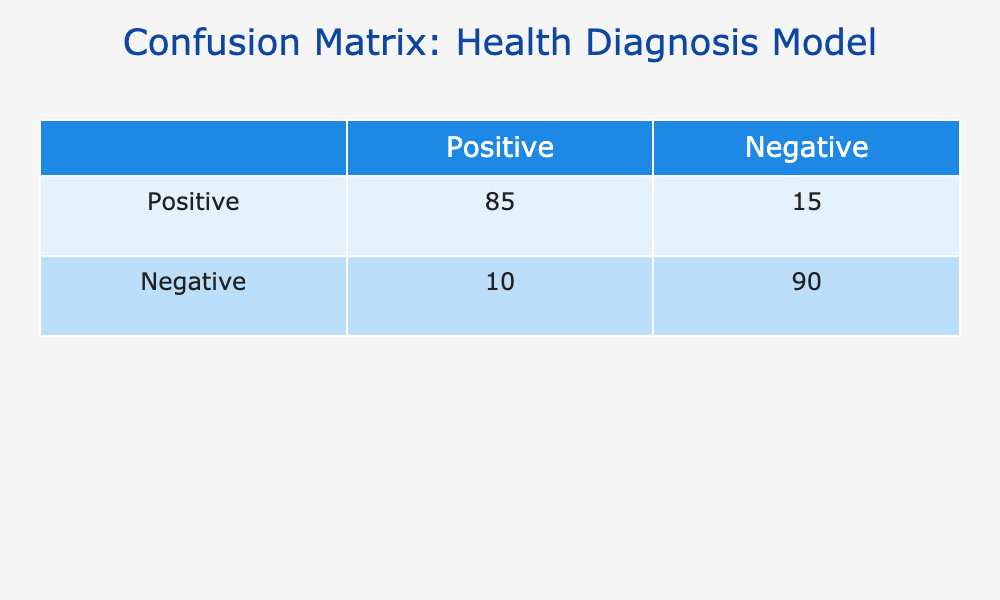What is the total number of positive predictions made by the model? To find the total number of positive predictions, look at the first column under "Predicted." The values are 85 (True Positives) and 10 (False Positives). Adding these two values gives 85 + 10 = 95.
Answer: 95 What is the total number of negative predictions made by the model? To find the total number of negative predictions, look at the second column under "Predicted." The values are 15 (False Negatives) and 90 (True Negatives). Adding these gives 15 + 90 = 105.
Answer: 105 What percentage of actual positive cases were correctly identified as positive? To find this percentage, divide the number of true positive cases (85) by the total actual positive cases (85 + 15 = 100), then multiply by 100 to convert to percentage. Thus, (85 / 100) * 100 = 85%.
Answer: 85% Is the model performing better in identifying positive or negative cases? To assess, we compare the true positive rate (85 out of 100) with the true negative rate (90 out of 100). Both rates are quite high, but the positive identification rate is 85% and negative is 90%. Since 90% is greater than 85%, the model performs better in identifying negative cases.
Answer: Yes What is the difference in the number of true positives and true negatives? To find this difference, simply subtract the number of true positives (85) from the number of true negatives (90). This gives 90 - 85 = 5.
Answer: 5 What is the overall accuracy of the model? The overall accuracy is calculated by taking the sum of true positives and true negatives, then dividing by the total number of cases (true positives + false positives + true negatives + false negatives). Hence, (85 + 90) / (85 + 15 + 10 + 90) = 175/200 = 0.875 or 87.5%.
Answer: 87.5% Are there more false negatives than false positives? To answer this, compare the false negatives (15) to the false positives (10). Since 15 is greater than 10, there are indeed more false negatives.
Answer: Yes What is the ratio of true positives to false negatives? To find the ratio, divide the number of true positives (85) by the number of false negatives (15). This results in a ratio of 85:15, which simplifies to 17:3.
Answer: 17:3 How many actual negative cases were incorrectly classified as positive? This is simply the number of false positives, which is stated directly in the table as 10.
Answer: 10 